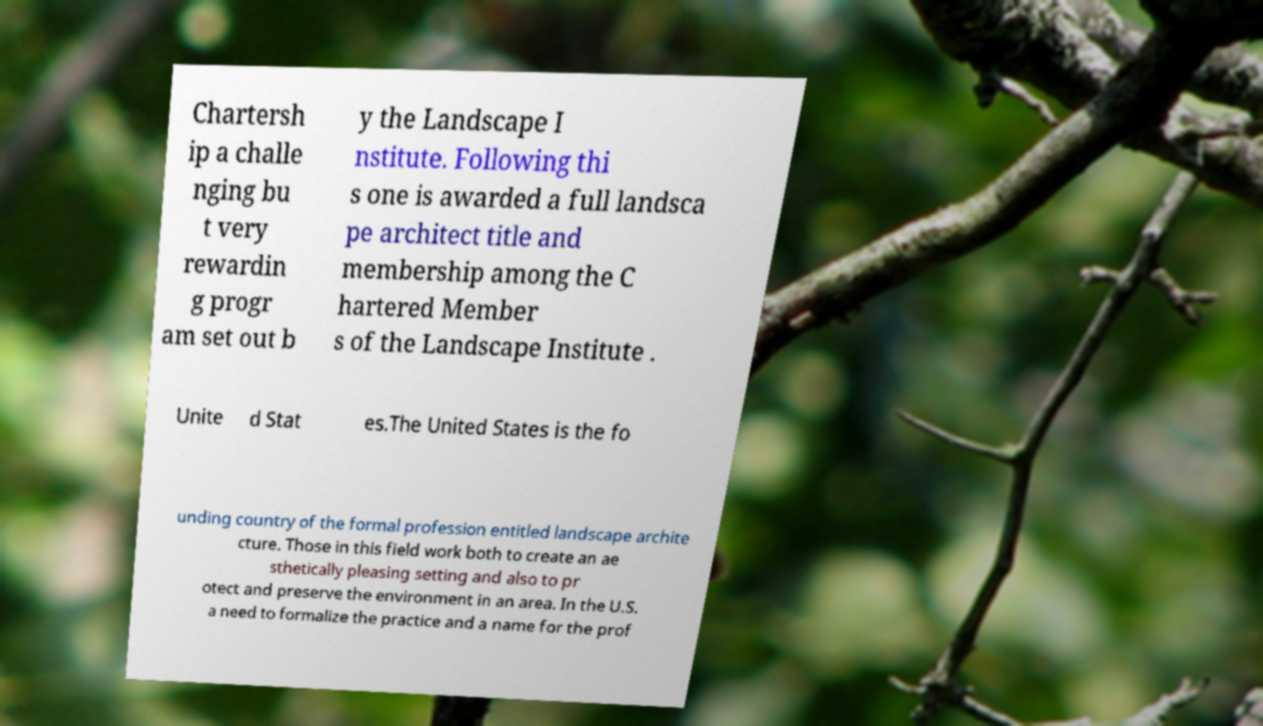What messages or text are displayed in this image? I need them in a readable, typed format. Chartersh ip a challe nging bu t very rewardin g progr am set out b y the Landscape I nstitute. Following thi s one is awarded a full landsca pe architect title and membership among the C hartered Member s of the Landscape Institute . Unite d Stat es.The United States is the fo unding country of the formal profession entitled landscape archite cture. Those in this field work both to create an ae sthetically pleasing setting and also to pr otect and preserve the environment in an area. In the U.S. a need to formalize the practice and a name for the prof 